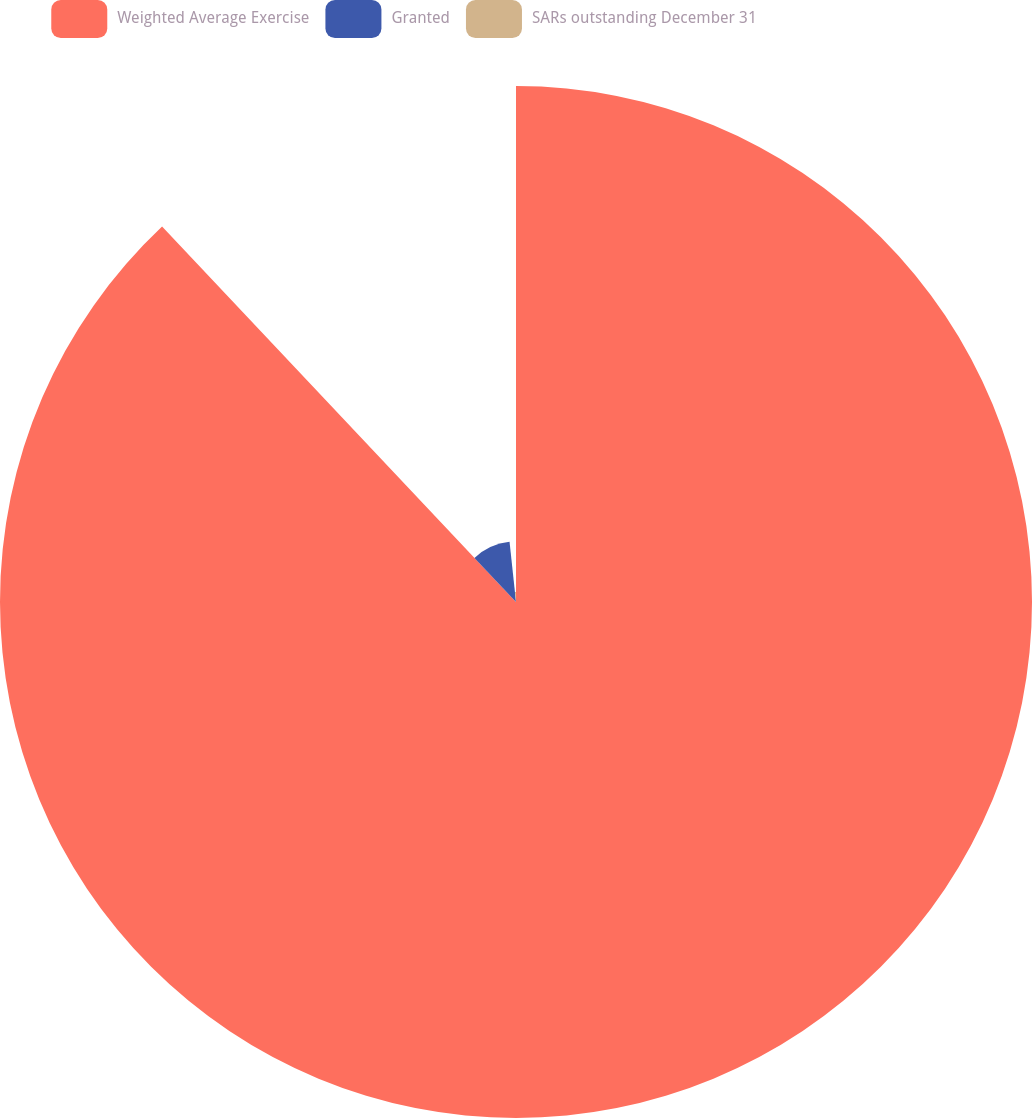Convert chart to OTSL. <chart><loc_0><loc_0><loc_500><loc_500><pie_chart><fcel>Weighted Average Exercise<fcel>Granted<fcel>SARs outstanding December 31<nl><fcel>87.97%<fcel>10.33%<fcel>1.7%<nl></chart> 